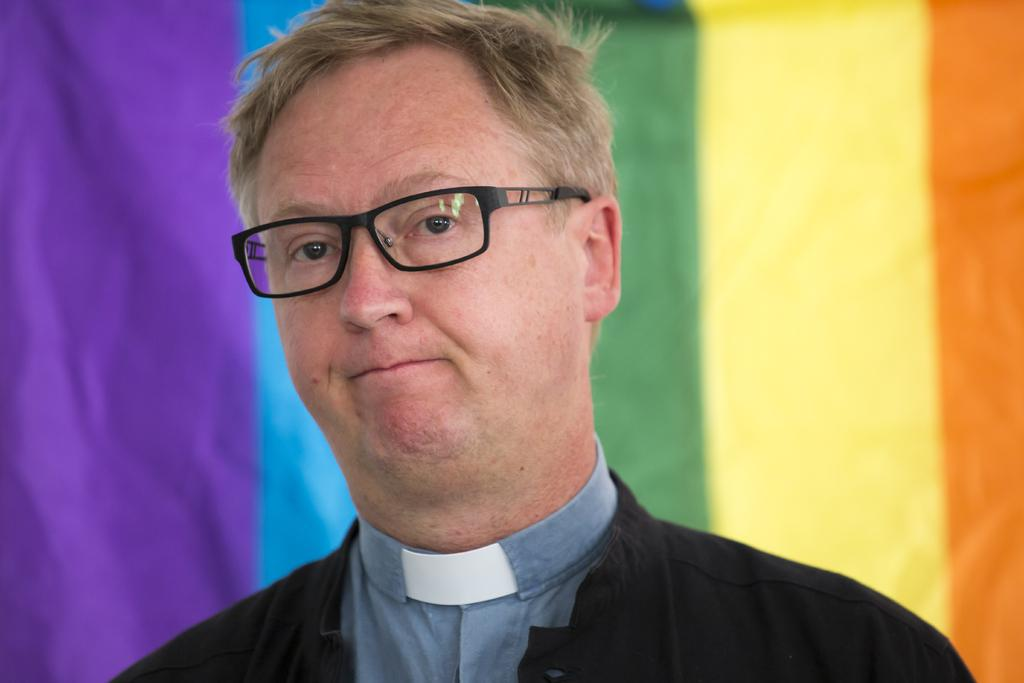Who is present in the image? There is a man in the image. What is the man wearing? The man is wearing a black shirt. What can be seen on the man's face? The man has black specks on his face. What is located behind the man in the image? There is a wall in the image. What decorations are on the wall? The wall has colorful paintings on it. What type of furniture is visible at the end of the image? There is no furniture visible in the image. 